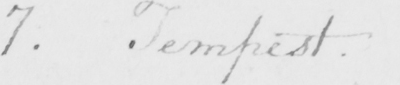What text is written in this handwritten line? 7 . Tempest . 